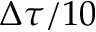Convert formula to latex. <formula><loc_0><loc_0><loc_500><loc_500>\Delta \tau / 1 0</formula> 